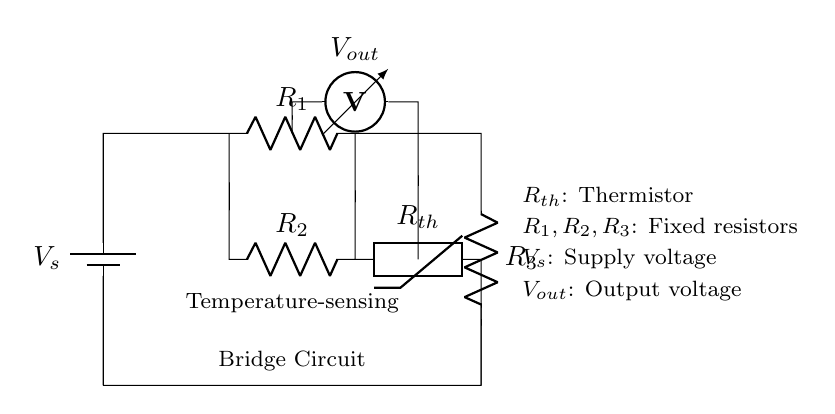What is the type of this circuit? This circuit is a bridge circuit, specifically designed for temperature sensing. The arrangement of the resistors and thermistor forms a setup that allows for the measurement of temperature based on resistance changes.
Answer: bridge circuit What component is used to sense temperature? The thermistor, labeled as Rth, is the component that senses temperature. It changes its resistance based on the surrounding temperature, which is crucial for the operation of this circuit.
Answer: thermistor How many resistors are in this circuit? There are three fixed resistors in the circuit, which are labeled as R1, R2, and R3. They are used to balance the bridge and work together with the thermistor for temperature sensing.
Answer: three What is the purpose of the output voltage in the circuit? The output voltage, labeled as Vout, provides a measurement signal that corresponds to the temperature sensed by the thermistor. This signal can be used for further processing, such as controlling an HVAC system.
Answer: measurement signal What would happen to Vout if the temperature increases? If the temperature increases, the resistance of the thermistor decreases, causing a change in the output voltage. The bridge circuit will become unbalanced, resulting in a higher Vout for an increase in temperature in most thermistor types.
Answer: Vout increases What is the role of the battery in the circuit? The battery, labeled as Vs, supplies the necessary voltage to the circuit components, providing a power source that allows them to function, specifically enabling the measurement of temperature.
Answer: power source 